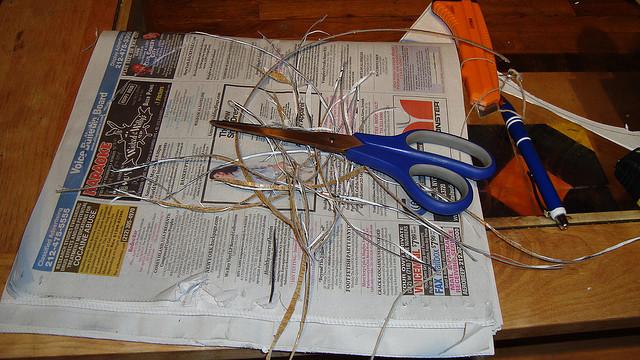What color are the scissor handles?
Keep it brief. Blue. What kind of craft is being done?
Short answer required. Not sure. Are the handles on the scissors blue?
Be succinct. Yes. What is being cut out?
Be succinct. Wire. What color is the pen?
Concise answer only. Blue. What color is the scissors?
Quick response, please. Blue. What is being cut?
Keep it brief. Twine. 